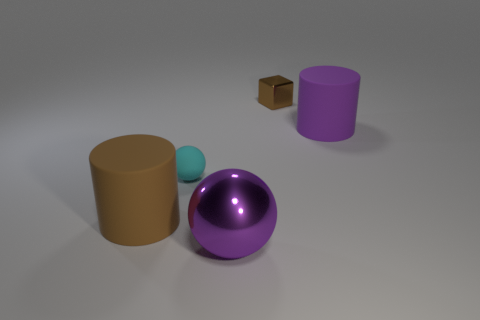Add 5 small brown metallic things. How many objects exist? 10 Subtract all balls. How many objects are left? 3 Subtract 1 cylinders. How many cylinders are left? 1 Subtract all red blocks. Subtract all yellow balls. How many blocks are left? 1 Subtract all cylinders. Subtract all purple cylinders. How many objects are left? 2 Add 5 large purple balls. How many large purple balls are left? 6 Add 4 big purple matte blocks. How many big purple matte blocks exist? 4 Subtract all purple cylinders. How many cylinders are left? 1 Subtract 0 red blocks. How many objects are left? 5 